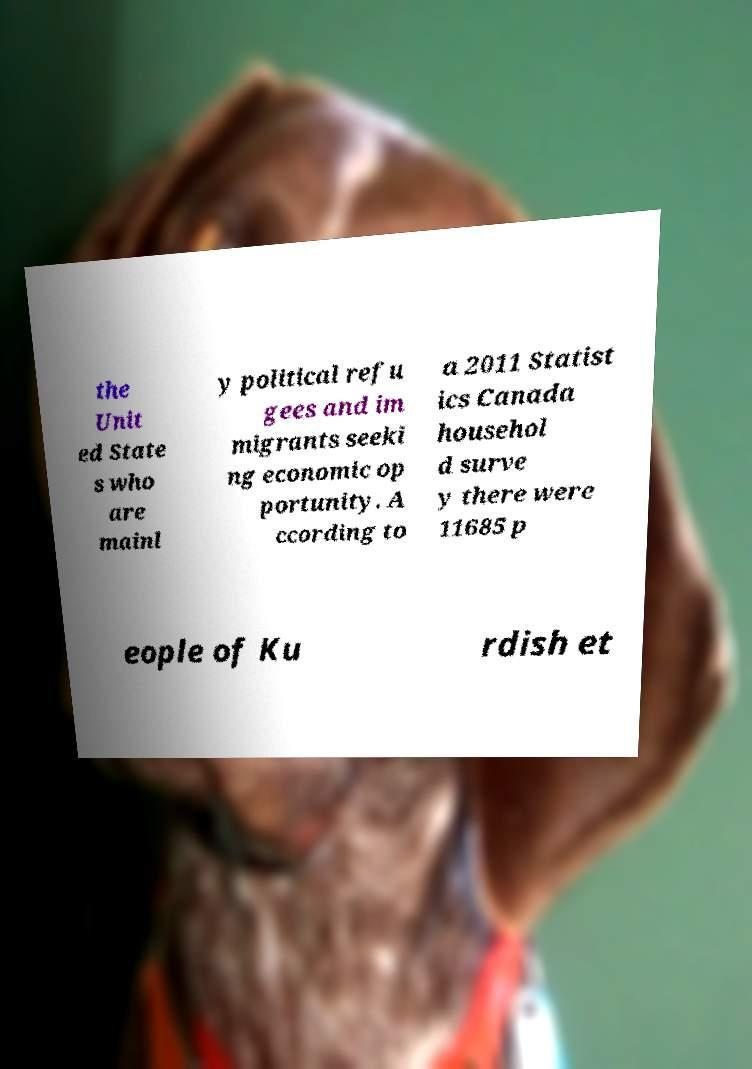Could you assist in decoding the text presented in this image and type it out clearly? the Unit ed State s who are mainl y political refu gees and im migrants seeki ng economic op portunity. A ccording to a 2011 Statist ics Canada househol d surve y there were 11685 p eople of Ku rdish et 